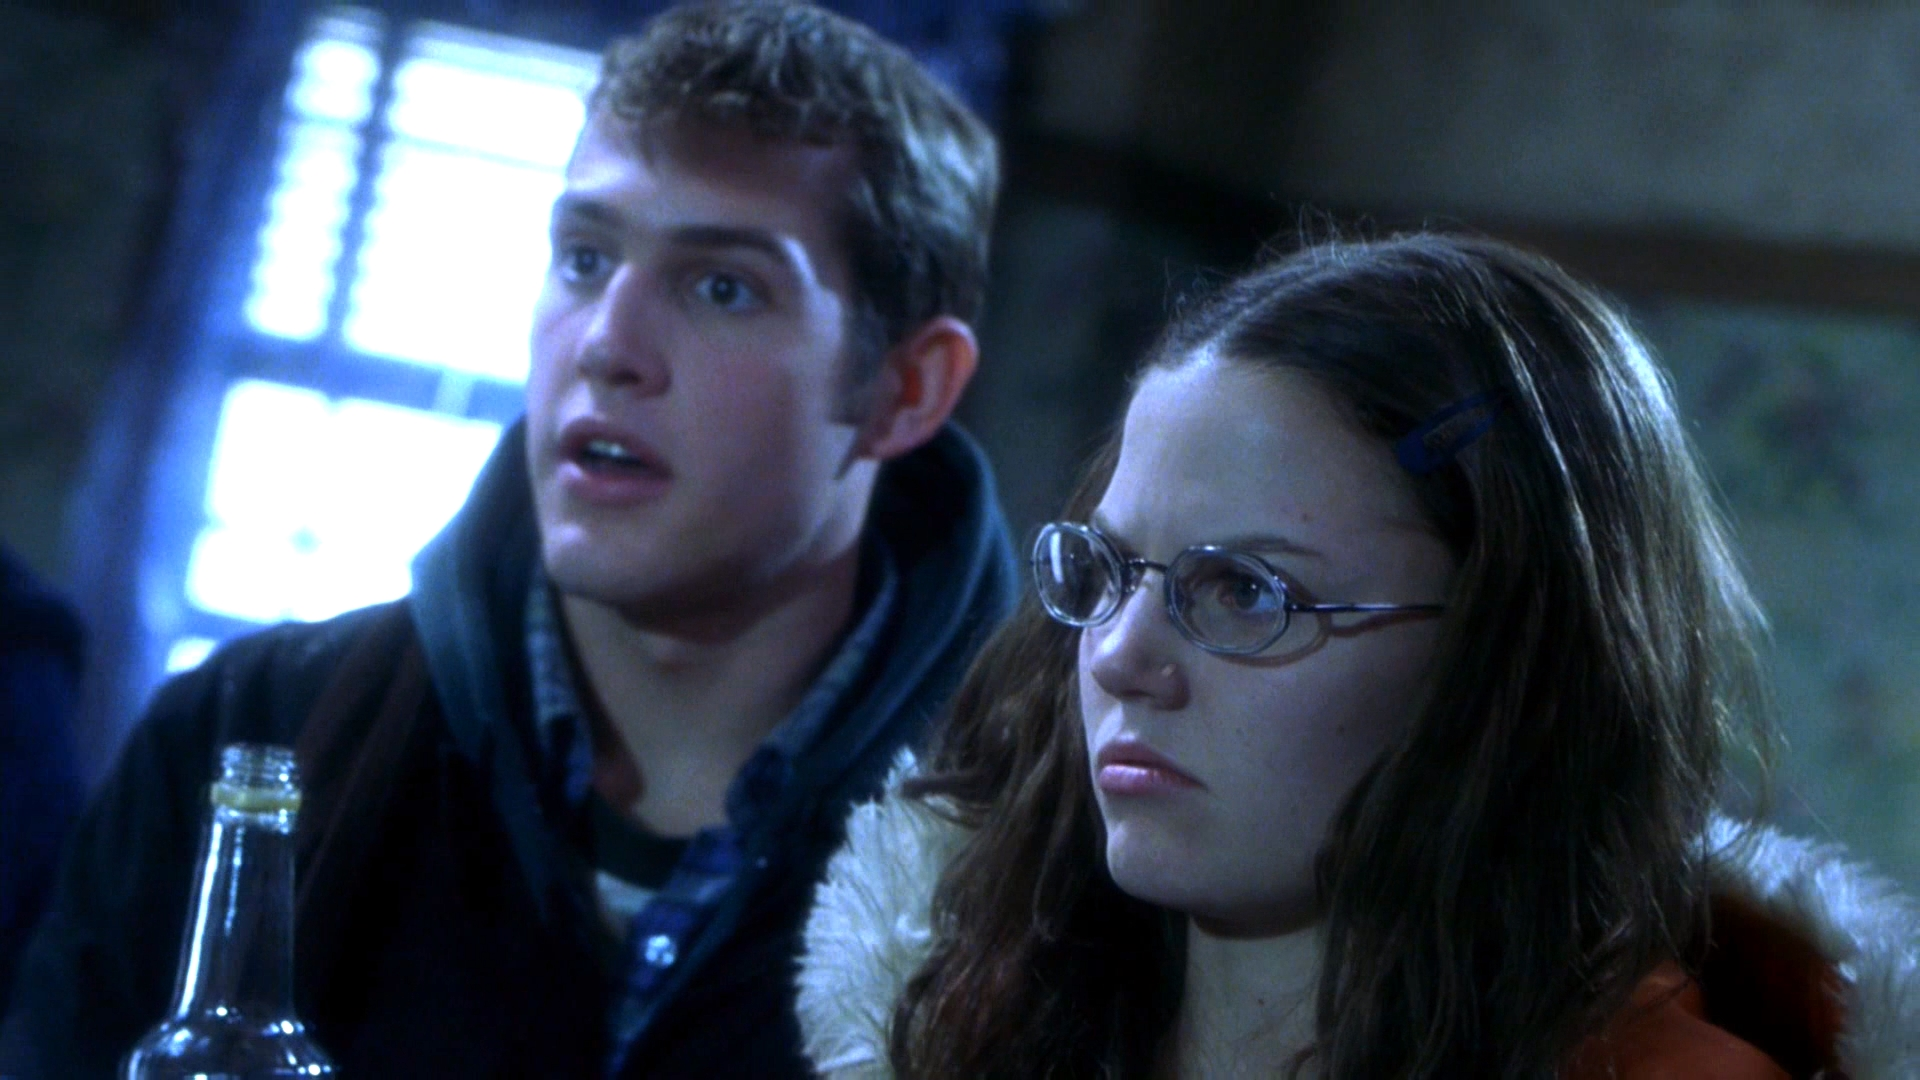Can you elaborate on the elements of the picture provided? In this image, we see a scene featuring two young individuals. The person on the right is a woman wearing glasses, a vibrant red jacket with a fur collar, and she appears to be holding a bottle in her hand. She has a focused and serious expression as she looks ahead. On the left side is a man in a blue jacket, looking in the sharegpt4v/same direction as the woman. His expression shows surprise or shock, with his mouth slightly open. The background is somewhat blurred, giving a sense of focus on the two characters and their emotions. 